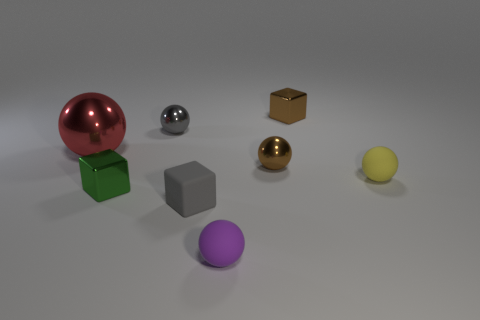Are there more tiny things than tiny green rubber blocks?
Give a very brief answer. Yes. What number of objects are either tiny metal cubes in front of the large red metallic ball or yellow rubber blocks?
Offer a very short reply. 1. Does the brown sphere have the same material as the small gray cube?
Your answer should be compact. No. There is a purple rubber object that is the same shape as the yellow rubber thing; what is its size?
Provide a short and direct response. Small. There is a tiny rubber object left of the small purple object; is its shape the same as the tiny rubber thing on the right side of the purple object?
Ensure brevity in your answer.  No. There is a purple rubber thing; does it have the same size as the brown metallic thing that is behind the large red metal ball?
Offer a terse response. Yes. What number of other objects are the same material as the tiny green object?
Keep it short and to the point. 4. Are there any other things that have the same shape as the tiny green object?
Make the answer very short. Yes. There is a small matte ball that is behind the small shiny block in front of the brown metal thing that is in front of the big sphere; what color is it?
Your answer should be very brief. Yellow. What is the shape of the tiny metallic thing that is in front of the red metal sphere and to the left of the brown metallic ball?
Your answer should be compact. Cube. 